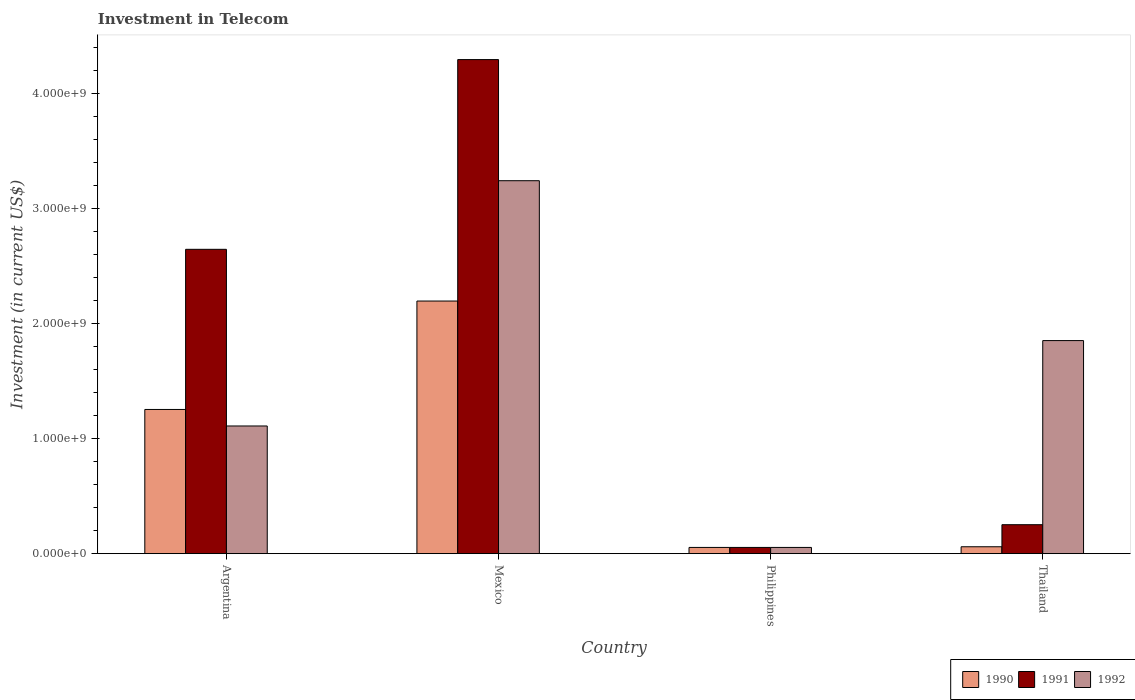How many different coloured bars are there?
Provide a succinct answer. 3. Are the number of bars on each tick of the X-axis equal?
Your response must be concise. Yes. How many bars are there on the 4th tick from the left?
Your answer should be compact. 3. What is the label of the 1st group of bars from the left?
Provide a succinct answer. Argentina. What is the amount invested in telecom in 1992 in Thailand?
Provide a short and direct response. 1.85e+09. Across all countries, what is the maximum amount invested in telecom in 1991?
Your response must be concise. 4.30e+09. Across all countries, what is the minimum amount invested in telecom in 1991?
Offer a terse response. 5.42e+07. In which country was the amount invested in telecom in 1992 minimum?
Your response must be concise. Philippines. What is the total amount invested in telecom in 1992 in the graph?
Your answer should be very brief. 6.26e+09. What is the difference between the amount invested in telecom in 1990 in Mexico and that in Thailand?
Keep it short and to the point. 2.14e+09. What is the difference between the amount invested in telecom in 1992 in Philippines and the amount invested in telecom in 1990 in Thailand?
Your answer should be very brief. -5.80e+06. What is the average amount invested in telecom in 1990 per country?
Your response must be concise. 8.92e+08. What is the ratio of the amount invested in telecom in 1990 in Mexico to that in Thailand?
Ensure brevity in your answer.  36.63. What is the difference between the highest and the second highest amount invested in telecom in 1990?
Offer a very short reply. 2.14e+09. What is the difference between the highest and the lowest amount invested in telecom in 1990?
Offer a very short reply. 2.14e+09. What does the 1st bar from the left in Mexico represents?
Your answer should be compact. 1990. How many bars are there?
Your response must be concise. 12. Are all the bars in the graph horizontal?
Offer a very short reply. No. What is the difference between two consecutive major ticks on the Y-axis?
Your response must be concise. 1.00e+09. Does the graph contain any zero values?
Offer a terse response. No. How many legend labels are there?
Offer a very short reply. 3. How are the legend labels stacked?
Your answer should be compact. Horizontal. What is the title of the graph?
Provide a succinct answer. Investment in Telecom. What is the label or title of the X-axis?
Provide a short and direct response. Country. What is the label or title of the Y-axis?
Provide a succinct answer. Investment (in current US$). What is the Investment (in current US$) of 1990 in Argentina?
Give a very brief answer. 1.25e+09. What is the Investment (in current US$) of 1991 in Argentina?
Make the answer very short. 2.65e+09. What is the Investment (in current US$) of 1992 in Argentina?
Give a very brief answer. 1.11e+09. What is the Investment (in current US$) of 1990 in Mexico?
Offer a very short reply. 2.20e+09. What is the Investment (in current US$) of 1991 in Mexico?
Keep it short and to the point. 4.30e+09. What is the Investment (in current US$) of 1992 in Mexico?
Ensure brevity in your answer.  3.24e+09. What is the Investment (in current US$) in 1990 in Philippines?
Provide a short and direct response. 5.42e+07. What is the Investment (in current US$) in 1991 in Philippines?
Offer a very short reply. 5.42e+07. What is the Investment (in current US$) in 1992 in Philippines?
Your answer should be very brief. 5.42e+07. What is the Investment (in current US$) in 1990 in Thailand?
Your response must be concise. 6.00e+07. What is the Investment (in current US$) in 1991 in Thailand?
Offer a terse response. 2.52e+08. What is the Investment (in current US$) of 1992 in Thailand?
Give a very brief answer. 1.85e+09. Across all countries, what is the maximum Investment (in current US$) of 1990?
Your answer should be compact. 2.20e+09. Across all countries, what is the maximum Investment (in current US$) in 1991?
Offer a very short reply. 4.30e+09. Across all countries, what is the maximum Investment (in current US$) of 1992?
Offer a very short reply. 3.24e+09. Across all countries, what is the minimum Investment (in current US$) of 1990?
Give a very brief answer. 5.42e+07. Across all countries, what is the minimum Investment (in current US$) of 1991?
Provide a short and direct response. 5.42e+07. Across all countries, what is the minimum Investment (in current US$) of 1992?
Provide a succinct answer. 5.42e+07. What is the total Investment (in current US$) of 1990 in the graph?
Provide a succinct answer. 3.57e+09. What is the total Investment (in current US$) in 1991 in the graph?
Make the answer very short. 7.25e+09. What is the total Investment (in current US$) in 1992 in the graph?
Your response must be concise. 6.26e+09. What is the difference between the Investment (in current US$) in 1990 in Argentina and that in Mexico?
Give a very brief answer. -9.43e+08. What is the difference between the Investment (in current US$) in 1991 in Argentina and that in Mexico?
Provide a succinct answer. -1.65e+09. What is the difference between the Investment (in current US$) in 1992 in Argentina and that in Mexico?
Make the answer very short. -2.13e+09. What is the difference between the Investment (in current US$) of 1990 in Argentina and that in Philippines?
Offer a terse response. 1.20e+09. What is the difference between the Investment (in current US$) in 1991 in Argentina and that in Philippines?
Offer a terse response. 2.59e+09. What is the difference between the Investment (in current US$) of 1992 in Argentina and that in Philippines?
Your response must be concise. 1.06e+09. What is the difference between the Investment (in current US$) of 1990 in Argentina and that in Thailand?
Keep it short and to the point. 1.19e+09. What is the difference between the Investment (in current US$) in 1991 in Argentina and that in Thailand?
Make the answer very short. 2.40e+09. What is the difference between the Investment (in current US$) of 1992 in Argentina and that in Thailand?
Your answer should be compact. -7.43e+08. What is the difference between the Investment (in current US$) of 1990 in Mexico and that in Philippines?
Provide a succinct answer. 2.14e+09. What is the difference between the Investment (in current US$) in 1991 in Mexico and that in Philippines?
Provide a succinct answer. 4.24e+09. What is the difference between the Investment (in current US$) of 1992 in Mexico and that in Philippines?
Offer a very short reply. 3.19e+09. What is the difference between the Investment (in current US$) in 1990 in Mexico and that in Thailand?
Provide a succinct answer. 2.14e+09. What is the difference between the Investment (in current US$) in 1991 in Mexico and that in Thailand?
Provide a succinct answer. 4.05e+09. What is the difference between the Investment (in current US$) in 1992 in Mexico and that in Thailand?
Offer a very short reply. 1.39e+09. What is the difference between the Investment (in current US$) of 1990 in Philippines and that in Thailand?
Offer a very short reply. -5.80e+06. What is the difference between the Investment (in current US$) of 1991 in Philippines and that in Thailand?
Keep it short and to the point. -1.98e+08. What is the difference between the Investment (in current US$) of 1992 in Philippines and that in Thailand?
Your response must be concise. -1.80e+09. What is the difference between the Investment (in current US$) in 1990 in Argentina and the Investment (in current US$) in 1991 in Mexico?
Offer a terse response. -3.04e+09. What is the difference between the Investment (in current US$) in 1990 in Argentina and the Investment (in current US$) in 1992 in Mexico?
Give a very brief answer. -1.99e+09. What is the difference between the Investment (in current US$) of 1991 in Argentina and the Investment (in current US$) of 1992 in Mexico?
Offer a very short reply. -5.97e+08. What is the difference between the Investment (in current US$) of 1990 in Argentina and the Investment (in current US$) of 1991 in Philippines?
Give a very brief answer. 1.20e+09. What is the difference between the Investment (in current US$) of 1990 in Argentina and the Investment (in current US$) of 1992 in Philippines?
Offer a terse response. 1.20e+09. What is the difference between the Investment (in current US$) of 1991 in Argentina and the Investment (in current US$) of 1992 in Philippines?
Provide a succinct answer. 2.59e+09. What is the difference between the Investment (in current US$) of 1990 in Argentina and the Investment (in current US$) of 1991 in Thailand?
Provide a short and direct response. 1.00e+09. What is the difference between the Investment (in current US$) of 1990 in Argentina and the Investment (in current US$) of 1992 in Thailand?
Give a very brief answer. -5.99e+08. What is the difference between the Investment (in current US$) in 1991 in Argentina and the Investment (in current US$) in 1992 in Thailand?
Ensure brevity in your answer.  7.94e+08. What is the difference between the Investment (in current US$) in 1990 in Mexico and the Investment (in current US$) in 1991 in Philippines?
Ensure brevity in your answer.  2.14e+09. What is the difference between the Investment (in current US$) of 1990 in Mexico and the Investment (in current US$) of 1992 in Philippines?
Offer a terse response. 2.14e+09. What is the difference between the Investment (in current US$) of 1991 in Mexico and the Investment (in current US$) of 1992 in Philippines?
Your response must be concise. 4.24e+09. What is the difference between the Investment (in current US$) in 1990 in Mexico and the Investment (in current US$) in 1991 in Thailand?
Your answer should be compact. 1.95e+09. What is the difference between the Investment (in current US$) in 1990 in Mexico and the Investment (in current US$) in 1992 in Thailand?
Ensure brevity in your answer.  3.44e+08. What is the difference between the Investment (in current US$) of 1991 in Mexico and the Investment (in current US$) of 1992 in Thailand?
Make the answer very short. 2.44e+09. What is the difference between the Investment (in current US$) in 1990 in Philippines and the Investment (in current US$) in 1991 in Thailand?
Provide a short and direct response. -1.98e+08. What is the difference between the Investment (in current US$) of 1990 in Philippines and the Investment (in current US$) of 1992 in Thailand?
Make the answer very short. -1.80e+09. What is the difference between the Investment (in current US$) of 1991 in Philippines and the Investment (in current US$) of 1992 in Thailand?
Provide a succinct answer. -1.80e+09. What is the average Investment (in current US$) of 1990 per country?
Your answer should be very brief. 8.92e+08. What is the average Investment (in current US$) of 1991 per country?
Your response must be concise. 1.81e+09. What is the average Investment (in current US$) of 1992 per country?
Offer a very short reply. 1.57e+09. What is the difference between the Investment (in current US$) in 1990 and Investment (in current US$) in 1991 in Argentina?
Make the answer very short. -1.39e+09. What is the difference between the Investment (in current US$) of 1990 and Investment (in current US$) of 1992 in Argentina?
Make the answer very short. 1.44e+08. What is the difference between the Investment (in current US$) in 1991 and Investment (in current US$) in 1992 in Argentina?
Offer a terse response. 1.54e+09. What is the difference between the Investment (in current US$) in 1990 and Investment (in current US$) in 1991 in Mexico?
Make the answer very short. -2.10e+09. What is the difference between the Investment (in current US$) of 1990 and Investment (in current US$) of 1992 in Mexico?
Keep it short and to the point. -1.05e+09. What is the difference between the Investment (in current US$) of 1991 and Investment (in current US$) of 1992 in Mexico?
Make the answer very short. 1.05e+09. What is the difference between the Investment (in current US$) of 1991 and Investment (in current US$) of 1992 in Philippines?
Ensure brevity in your answer.  0. What is the difference between the Investment (in current US$) of 1990 and Investment (in current US$) of 1991 in Thailand?
Your answer should be compact. -1.92e+08. What is the difference between the Investment (in current US$) in 1990 and Investment (in current US$) in 1992 in Thailand?
Your answer should be very brief. -1.79e+09. What is the difference between the Investment (in current US$) of 1991 and Investment (in current US$) of 1992 in Thailand?
Ensure brevity in your answer.  -1.60e+09. What is the ratio of the Investment (in current US$) of 1990 in Argentina to that in Mexico?
Offer a very short reply. 0.57. What is the ratio of the Investment (in current US$) in 1991 in Argentina to that in Mexico?
Provide a short and direct response. 0.62. What is the ratio of the Investment (in current US$) in 1992 in Argentina to that in Mexico?
Your answer should be very brief. 0.34. What is the ratio of the Investment (in current US$) in 1990 in Argentina to that in Philippines?
Provide a short and direct response. 23.15. What is the ratio of the Investment (in current US$) in 1991 in Argentina to that in Philippines?
Your answer should be very brief. 48.86. What is the ratio of the Investment (in current US$) in 1992 in Argentina to that in Philippines?
Provide a succinct answer. 20.5. What is the ratio of the Investment (in current US$) in 1990 in Argentina to that in Thailand?
Provide a succinct answer. 20.91. What is the ratio of the Investment (in current US$) in 1991 in Argentina to that in Thailand?
Your response must be concise. 10.51. What is the ratio of the Investment (in current US$) in 1992 in Argentina to that in Thailand?
Provide a succinct answer. 0.6. What is the ratio of the Investment (in current US$) in 1990 in Mexico to that in Philippines?
Make the answer very short. 40.55. What is the ratio of the Investment (in current US$) of 1991 in Mexico to that in Philippines?
Keep it short and to the point. 79.32. What is the ratio of the Investment (in current US$) of 1992 in Mexico to that in Philippines?
Provide a short and direct response. 59.87. What is the ratio of the Investment (in current US$) in 1990 in Mexico to that in Thailand?
Provide a succinct answer. 36.63. What is the ratio of the Investment (in current US$) of 1991 in Mexico to that in Thailand?
Provide a short and direct response. 17.06. What is the ratio of the Investment (in current US$) in 1992 in Mexico to that in Thailand?
Provide a short and direct response. 1.75. What is the ratio of the Investment (in current US$) of 1990 in Philippines to that in Thailand?
Your response must be concise. 0.9. What is the ratio of the Investment (in current US$) in 1991 in Philippines to that in Thailand?
Provide a succinct answer. 0.22. What is the ratio of the Investment (in current US$) in 1992 in Philippines to that in Thailand?
Provide a short and direct response. 0.03. What is the difference between the highest and the second highest Investment (in current US$) in 1990?
Keep it short and to the point. 9.43e+08. What is the difference between the highest and the second highest Investment (in current US$) in 1991?
Your response must be concise. 1.65e+09. What is the difference between the highest and the second highest Investment (in current US$) in 1992?
Your response must be concise. 1.39e+09. What is the difference between the highest and the lowest Investment (in current US$) of 1990?
Make the answer very short. 2.14e+09. What is the difference between the highest and the lowest Investment (in current US$) in 1991?
Your answer should be compact. 4.24e+09. What is the difference between the highest and the lowest Investment (in current US$) in 1992?
Ensure brevity in your answer.  3.19e+09. 